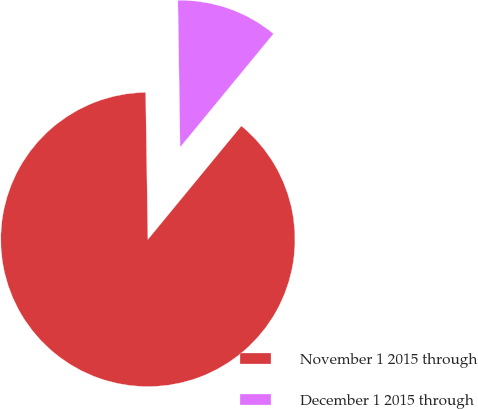<chart> <loc_0><loc_0><loc_500><loc_500><pie_chart><fcel>November 1 2015 through<fcel>December 1 2015 through<nl><fcel>88.8%<fcel>11.2%<nl></chart> 